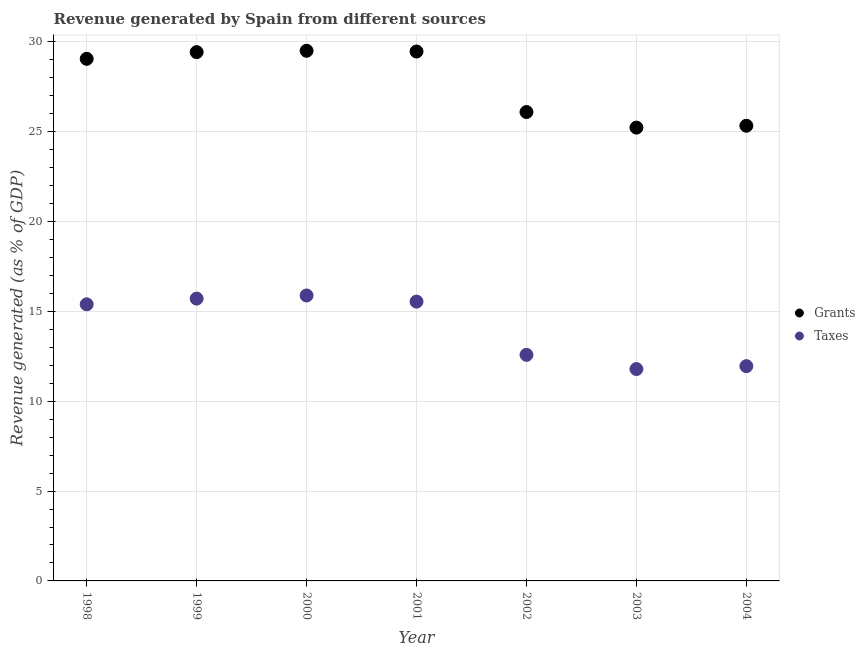What is the revenue generated by grants in 2003?
Offer a terse response. 25.23. Across all years, what is the maximum revenue generated by grants?
Provide a succinct answer. 29.5. Across all years, what is the minimum revenue generated by taxes?
Make the answer very short. 11.79. In which year was the revenue generated by grants maximum?
Your response must be concise. 2000. In which year was the revenue generated by grants minimum?
Ensure brevity in your answer.  2003. What is the total revenue generated by grants in the graph?
Keep it short and to the point. 194.12. What is the difference between the revenue generated by taxes in 2001 and that in 2003?
Your answer should be compact. 3.75. What is the difference between the revenue generated by grants in 1999 and the revenue generated by taxes in 2004?
Offer a very short reply. 17.48. What is the average revenue generated by taxes per year?
Provide a short and direct response. 14.12. In the year 2002, what is the difference between the revenue generated by grants and revenue generated by taxes?
Make the answer very short. 13.51. In how many years, is the revenue generated by taxes greater than 24 %?
Offer a very short reply. 0. What is the ratio of the revenue generated by taxes in 1998 to that in 2002?
Offer a very short reply. 1.22. What is the difference between the highest and the second highest revenue generated by taxes?
Provide a succinct answer. 0.17. What is the difference between the highest and the lowest revenue generated by taxes?
Ensure brevity in your answer.  4.09. In how many years, is the revenue generated by taxes greater than the average revenue generated by taxes taken over all years?
Offer a terse response. 4. Does the revenue generated by grants monotonically increase over the years?
Provide a succinct answer. No. How many dotlines are there?
Provide a short and direct response. 2. How many years are there in the graph?
Provide a short and direct response. 7. What is the difference between two consecutive major ticks on the Y-axis?
Your response must be concise. 5. Does the graph contain grids?
Keep it short and to the point. Yes. What is the title of the graph?
Your answer should be very brief. Revenue generated by Spain from different sources. What is the label or title of the Y-axis?
Give a very brief answer. Revenue generated (as % of GDP). What is the Revenue generated (as % of GDP) in Grants in 1998?
Provide a short and direct response. 29.06. What is the Revenue generated (as % of GDP) of Taxes in 1998?
Ensure brevity in your answer.  15.4. What is the Revenue generated (as % of GDP) in Grants in 1999?
Your answer should be compact. 29.43. What is the Revenue generated (as % of GDP) in Taxes in 1999?
Offer a terse response. 15.71. What is the Revenue generated (as % of GDP) of Grants in 2000?
Give a very brief answer. 29.5. What is the Revenue generated (as % of GDP) in Taxes in 2000?
Your answer should be very brief. 15.89. What is the Revenue generated (as % of GDP) of Grants in 2001?
Keep it short and to the point. 29.47. What is the Revenue generated (as % of GDP) of Taxes in 2001?
Provide a short and direct response. 15.55. What is the Revenue generated (as % of GDP) in Grants in 2002?
Give a very brief answer. 26.1. What is the Revenue generated (as % of GDP) in Taxes in 2002?
Give a very brief answer. 12.58. What is the Revenue generated (as % of GDP) of Grants in 2003?
Offer a terse response. 25.23. What is the Revenue generated (as % of GDP) in Taxes in 2003?
Provide a short and direct response. 11.79. What is the Revenue generated (as % of GDP) of Grants in 2004?
Offer a terse response. 25.33. What is the Revenue generated (as % of GDP) of Taxes in 2004?
Make the answer very short. 11.95. Across all years, what is the maximum Revenue generated (as % of GDP) of Grants?
Offer a very short reply. 29.5. Across all years, what is the maximum Revenue generated (as % of GDP) in Taxes?
Offer a terse response. 15.89. Across all years, what is the minimum Revenue generated (as % of GDP) in Grants?
Your response must be concise. 25.23. Across all years, what is the minimum Revenue generated (as % of GDP) of Taxes?
Your answer should be compact. 11.79. What is the total Revenue generated (as % of GDP) of Grants in the graph?
Your answer should be compact. 194.12. What is the total Revenue generated (as % of GDP) of Taxes in the graph?
Offer a terse response. 98.87. What is the difference between the Revenue generated (as % of GDP) of Grants in 1998 and that in 1999?
Make the answer very short. -0.37. What is the difference between the Revenue generated (as % of GDP) in Taxes in 1998 and that in 1999?
Give a very brief answer. -0.32. What is the difference between the Revenue generated (as % of GDP) of Grants in 1998 and that in 2000?
Your answer should be very brief. -0.45. What is the difference between the Revenue generated (as % of GDP) of Taxes in 1998 and that in 2000?
Your response must be concise. -0.49. What is the difference between the Revenue generated (as % of GDP) of Grants in 1998 and that in 2001?
Ensure brevity in your answer.  -0.41. What is the difference between the Revenue generated (as % of GDP) of Taxes in 1998 and that in 2001?
Your answer should be very brief. -0.15. What is the difference between the Revenue generated (as % of GDP) in Grants in 1998 and that in 2002?
Your response must be concise. 2.96. What is the difference between the Revenue generated (as % of GDP) in Taxes in 1998 and that in 2002?
Keep it short and to the point. 2.81. What is the difference between the Revenue generated (as % of GDP) of Grants in 1998 and that in 2003?
Offer a terse response. 3.83. What is the difference between the Revenue generated (as % of GDP) in Taxes in 1998 and that in 2003?
Your answer should be very brief. 3.6. What is the difference between the Revenue generated (as % of GDP) of Grants in 1998 and that in 2004?
Give a very brief answer. 3.72. What is the difference between the Revenue generated (as % of GDP) of Taxes in 1998 and that in 2004?
Offer a terse response. 3.44. What is the difference between the Revenue generated (as % of GDP) of Grants in 1999 and that in 2000?
Your response must be concise. -0.07. What is the difference between the Revenue generated (as % of GDP) of Taxes in 1999 and that in 2000?
Ensure brevity in your answer.  -0.17. What is the difference between the Revenue generated (as % of GDP) in Grants in 1999 and that in 2001?
Your answer should be compact. -0.03. What is the difference between the Revenue generated (as % of GDP) in Taxes in 1999 and that in 2001?
Offer a terse response. 0.17. What is the difference between the Revenue generated (as % of GDP) in Grants in 1999 and that in 2002?
Give a very brief answer. 3.33. What is the difference between the Revenue generated (as % of GDP) in Taxes in 1999 and that in 2002?
Ensure brevity in your answer.  3.13. What is the difference between the Revenue generated (as % of GDP) in Grants in 1999 and that in 2003?
Offer a terse response. 4.2. What is the difference between the Revenue generated (as % of GDP) of Taxes in 1999 and that in 2003?
Offer a terse response. 3.92. What is the difference between the Revenue generated (as % of GDP) in Grants in 1999 and that in 2004?
Ensure brevity in your answer.  4.1. What is the difference between the Revenue generated (as % of GDP) of Taxes in 1999 and that in 2004?
Make the answer very short. 3.76. What is the difference between the Revenue generated (as % of GDP) in Grants in 2000 and that in 2001?
Make the answer very short. 0.04. What is the difference between the Revenue generated (as % of GDP) of Taxes in 2000 and that in 2001?
Your response must be concise. 0.34. What is the difference between the Revenue generated (as % of GDP) of Grants in 2000 and that in 2002?
Provide a succinct answer. 3.41. What is the difference between the Revenue generated (as % of GDP) in Taxes in 2000 and that in 2002?
Provide a short and direct response. 3.3. What is the difference between the Revenue generated (as % of GDP) of Grants in 2000 and that in 2003?
Your answer should be very brief. 4.28. What is the difference between the Revenue generated (as % of GDP) in Taxes in 2000 and that in 2003?
Keep it short and to the point. 4.09. What is the difference between the Revenue generated (as % of GDP) of Grants in 2000 and that in 2004?
Your response must be concise. 4.17. What is the difference between the Revenue generated (as % of GDP) of Taxes in 2000 and that in 2004?
Make the answer very short. 3.93. What is the difference between the Revenue generated (as % of GDP) in Grants in 2001 and that in 2002?
Give a very brief answer. 3.37. What is the difference between the Revenue generated (as % of GDP) of Taxes in 2001 and that in 2002?
Your response must be concise. 2.96. What is the difference between the Revenue generated (as % of GDP) in Grants in 2001 and that in 2003?
Your answer should be compact. 4.24. What is the difference between the Revenue generated (as % of GDP) in Taxes in 2001 and that in 2003?
Provide a short and direct response. 3.75. What is the difference between the Revenue generated (as % of GDP) in Grants in 2001 and that in 2004?
Provide a succinct answer. 4.13. What is the difference between the Revenue generated (as % of GDP) of Taxes in 2001 and that in 2004?
Make the answer very short. 3.59. What is the difference between the Revenue generated (as % of GDP) in Grants in 2002 and that in 2003?
Your response must be concise. 0.87. What is the difference between the Revenue generated (as % of GDP) of Taxes in 2002 and that in 2003?
Give a very brief answer. 0.79. What is the difference between the Revenue generated (as % of GDP) of Grants in 2002 and that in 2004?
Offer a very short reply. 0.76. What is the difference between the Revenue generated (as % of GDP) of Taxes in 2002 and that in 2004?
Offer a very short reply. 0.63. What is the difference between the Revenue generated (as % of GDP) in Grants in 2003 and that in 2004?
Provide a short and direct response. -0.1. What is the difference between the Revenue generated (as % of GDP) of Taxes in 2003 and that in 2004?
Offer a terse response. -0.16. What is the difference between the Revenue generated (as % of GDP) in Grants in 1998 and the Revenue generated (as % of GDP) in Taxes in 1999?
Ensure brevity in your answer.  13.35. What is the difference between the Revenue generated (as % of GDP) in Grants in 1998 and the Revenue generated (as % of GDP) in Taxes in 2000?
Make the answer very short. 13.17. What is the difference between the Revenue generated (as % of GDP) of Grants in 1998 and the Revenue generated (as % of GDP) of Taxes in 2001?
Offer a very short reply. 13.51. What is the difference between the Revenue generated (as % of GDP) of Grants in 1998 and the Revenue generated (as % of GDP) of Taxes in 2002?
Keep it short and to the point. 16.48. What is the difference between the Revenue generated (as % of GDP) in Grants in 1998 and the Revenue generated (as % of GDP) in Taxes in 2003?
Your response must be concise. 17.27. What is the difference between the Revenue generated (as % of GDP) in Grants in 1998 and the Revenue generated (as % of GDP) in Taxes in 2004?
Offer a terse response. 17.1. What is the difference between the Revenue generated (as % of GDP) in Grants in 1999 and the Revenue generated (as % of GDP) in Taxes in 2000?
Provide a succinct answer. 13.54. What is the difference between the Revenue generated (as % of GDP) of Grants in 1999 and the Revenue generated (as % of GDP) of Taxes in 2001?
Keep it short and to the point. 13.88. What is the difference between the Revenue generated (as % of GDP) in Grants in 1999 and the Revenue generated (as % of GDP) in Taxes in 2002?
Provide a short and direct response. 16.85. What is the difference between the Revenue generated (as % of GDP) in Grants in 1999 and the Revenue generated (as % of GDP) in Taxes in 2003?
Your response must be concise. 17.64. What is the difference between the Revenue generated (as % of GDP) of Grants in 1999 and the Revenue generated (as % of GDP) of Taxes in 2004?
Provide a short and direct response. 17.48. What is the difference between the Revenue generated (as % of GDP) of Grants in 2000 and the Revenue generated (as % of GDP) of Taxes in 2001?
Your answer should be compact. 13.96. What is the difference between the Revenue generated (as % of GDP) in Grants in 2000 and the Revenue generated (as % of GDP) in Taxes in 2002?
Keep it short and to the point. 16.92. What is the difference between the Revenue generated (as % of GDP) in Grants in 2000 and the Revenue generated (as % of GDP) in Taxes in 2003?
Provide a succinct answer. 17.71. What is the difference between the Revenue generated (as % of GDP) in Grants in 2000 and the Revenue generated (as % of GDP) in Taxes in 2004?
Your answer should be compact. 17.55. What is the difference between the Revenue generated (as % of GDP) in Grants in 2001 and the Revenue generated (as % of GDP) in Taxes in 2002?
Give a very brief answer. 16.88. What is the difference between the Revenue generated (as % of GDP) of Grants in 2001 and the Revenue generated (as % of GDP) of Taxes in 2003?
Your answer should be very brief. 17.67. What is the difference between the Revenue generated (as % of GDP) in Grants in 2001 and the Revenue generated (as % of GDP) in Taxes in 2004?
Offer a very short reply. 17.51. What is the difference between the Revenue generated (as % of GDP) of Grants in 2002 and the Revenue generated (as % of GDP) of Taxes in 2003?
Provide a succinct answer. 14.3. What is the difference between the Revenue generated (as % of GDP) in Grants in 2002 and the Revenue generated (as % of GDP) in Taxes in 2004?
Give a very brief answer. 14.14. What is the difference between the Revenue generated (as % of GDP) in Grants in 2003 and the Revenue generated (as % of GDP) in Taxes in 2004?
Provide a short and direct response. 13.28. What is the average Revenue generated (as % of GDP) of Grants per year?
Offer a terse response. 27.73. What is the average Revenue generated (as % of GDP) of Taxes per year?
Provide a succinct answer. 14.12. In the year 1998, what is the difference between the Revenue generated (as % of GDP) of Grants and Revenue generated (as % of GDP) of Taxes?
Give a very brief answer. 13.66. In the year 1999, what is the difference between the Revenue generated (as % of GDP) of Grants and Revenue generated (as % of GDP) of Taxes?
Provide a short and direct response. 13.72. In the year 2000, what is the difference between the Revenue generated (as % of GDP) in Grants and Revenue generated (as % of GDP) in Taxes?
Your answer should be compact. 13.62. In the year 2001, what is the difference between the Revenue generated (as % of GDP) of Grants and Revenue generated (as % of GDP) of Taxes?
Your response must be concise. 13.92. In the year 2002, what is the difference between the Revenue generated (as % of GDP) of Grants and Revenue generated (as % of GDP) of Taxes?
Make the answer very short. 13.51. In the year 2003, what is the difference between the Revenue generated (as % of GDP) of Grants and Revenue generated (as % of GDP) of Taxes?
Make the answer very short. 13.44. In the year 2004, what is the difference between the Revenue generated (as % of GDP) in Grants and Revenue generated (as % of GDP) in Taxes?
Ensure brevity in your answer.  13.38. What is the ratio of the Revenue generated (as % of GDP) in Grants in 1998 to that in 1999?
Offer a terse response. 0.99. What is the ratio of the Revenue generated (as % of GDP) of Taxes in 1998 to that in 1999?
Offer a very short reply. 0.98. What is the ratio of the Revenue generated (as % of GDP) in Grants in 1998 to that in 2000?
Ensure brevity in your answer.  0.98. What is the ratio of the Revenue generated (as % of GDP) of Taxes in 1998 to that in 2000?
Ensure brevity in your answer.  0.97. What is the ratio of the Revenue generated (as % of GDP) of Grants in 1998 to that in 2001?
Provide a short and direct response. 0.99. What is the ratio of the Revenue generated (as % of GDP) of Grants in 1998 to that in 2002?
Make the answer very short. 1.11. What is the ratio of the Revenue generated (as % of GDP) in Taxes in 1998 to that in 2002?
Give a very brief answer. 1.22. What is the ratio of the Revenue generated (as % of GDP) of Grants in 1998 to that in 2003?
Make the answer very short. 1.15. What is the ratio of the Revenue generated (as % of GDP) in Taxes in 1998 to that in 2003?
Offer a terse response. 1.31. What is the ratio of the Revenue generated (as % of GDP) of Grants in 1998 to that in 2004?
Provide a short and direct response. 1.15. What is the ratio of the Revenue generated (as % of GDP) of Taxes in 1998 to that in 2004?
Your answer should be compact. 1.29. What is the ratio of the Revenue generated (as % of GDP) of Taxes in 1999 to that in 2000?
Give a very brief answer. 0.99. What is the ratio of the Revenue generated (as % of GDP) in Grants in 1999 to that in 2001?
Offer a very short reply. 1. What is the ratio of the Revenue generated (as % of GDP) of Taxes in 1999 to that in 2001?
Offer a terse response. 1.01. What is the ratio of the Revenue generated (as % of GDP) of Grants in 1999 to that in 2002?
Offer a very short reply. 1.13. What is the ratio of the Revenue generated (as % of GDP) of Taxes in 1999 to that in 2002?
Make the answer very short. 1.25. What is the ratio of the Revenue generated (as % of GDP) of Grants in 1999 to that in 2003?
Give a very brief answer. 1.17. What is the ratio of the Revenue generated (as % of GDP) in Taxes in 1999 to that in 2003?
Ensure brevity in your answer.  1.33. What is the ratio of the Revenue generated (as % of GDP) in Grants in 1999 to that in 2004?
Ensure brevity in your answer.  1.16. What is the ratio of the Revenue generated (as % of GDP) in Taxes in 1999 to that in 2004?
Keep it short and to the point. 1.31. What is the ratio of the Revenue generated (as % of GDP) in Grants in 2000 to that in 2001?
Your response must be concise. 1. What is the ratio of the Revenue generated (as % of GDP) of Taxes in 2000 to that in 2001?
Provide a succinct answer. 1.02. What is the ratio of the Revenue generated (as % of GDP) of Grants in 2000 to that in 2002?
Your response must be concise. 1.13. What is the ratio of the Revenue generated (as % of GDP) of Taxes in 2000 to that in 2002?
Make the answer very short. 1.26. What is the ratio of the Revenue generated (as % of GDP) of Grants in 2000 to that in 2003?
Ensure brevity in your answer.  1.17. What is the ratio of the Revenue generated (as % of GDP) in Taxes in 2000 to that in 2003?
Your answer should be compact. 1.35. What is the ratio of the Revenue generated (as % of GDP) in Grants in 2000 to that in 2004?
Your response must be concise. 1.16. What is the ratio of the Revenue generated (as % of GDP) of Taxes in 2000 to that in 2004?
Provide a succinct answer. 1.33. What is the ratio of the Revenue generated (as % of GDP) of Grants in 2001 to that in 2002?
Keep it short and to the point. 1.13. What is the ratio of the Revenue generated (as % of GDP) of Taxes in 2001 to that in 2002?
Your response must be concise. 1.24. What is the ratio of the Revenue generated (as % of GDP) of Grants in 2001 to that in 2003?
Ensure brevity in your answer.  1.17. What is the ratio of the Revenue generated (as % of GDP) of Taxes in 2001 to that in 2003?
Your response must be concise. 1.32. What is the ratio of the Revenue generated (as % of GDP) in Grants in 2001 to that in 2004?
Offer a terse response. 1.16. What is the ratio of the Revenue generated (as % of GDP) in Taxes in 2001 to that in 2004?
Provide a short and direct response. 1.3. What is the ratio of the Revenue generated (as % of GDP) in Grants in 2002 to that in 2003?
Give a very brief answer. 1.03. What is the ratio of the Revenue generated (as % of GDP) in Taxes in 2002 to that in 2003?
Provide a succinct answer. 1.07. What is the ratio of the Revenue generated (as % of GDP) of Grants in 2002 to that in 2004?
Provide a succinct answer. 1.03. What is the ratio of the Revenue generated (as % of GDP) of Taxes in 2002 to that in 2004?
Ensure brevity in your answer.  1.05. What is the ratio of the Revenue generated (as % of GDP) in Taxes in 2003 to that in 2004?
Your response must be concise. 0.99. What is the difference between the highest and the second highest Revenue generated (as % of GDP) of Grants?
Your response must be concise. 0.04. What is the difference between the highest and the second highest Revenue generated (as % of GDP) in Taxes?
Make the answer very short. 0.17. What is the difference between the highest and the lowest Revenue generated (as % of GDP) of Grants?
Your answer should be very brief. 4.28. What is the difference between the highest and the lowest Revenue generated (as % of GDP) in Taxes?
Offer a very short reply. 4.09. 